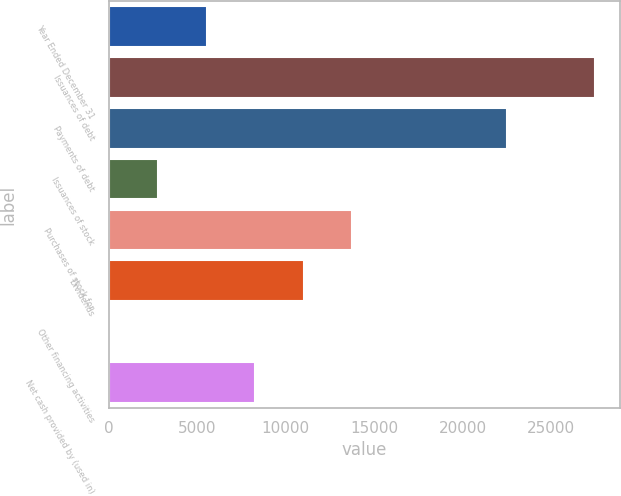<chart> <loc_0><loc_0><loc_500><loc_500><bar_chart><fcel>Year Ended December 31<fcel>Issuances of debt<fcel>Payments of debt<fcel>Issuances of stock<fcel>Purchases of stock for<fcel>Dividends<fcel>Other financing activities<fcel>Net cash provided by (used in)<nl><fcel>5535<fcel>27495<fcel>22530<fcel>2790<fcel>13770<fcel>11025<fcel>45<fcel>8280<nl></chart> 